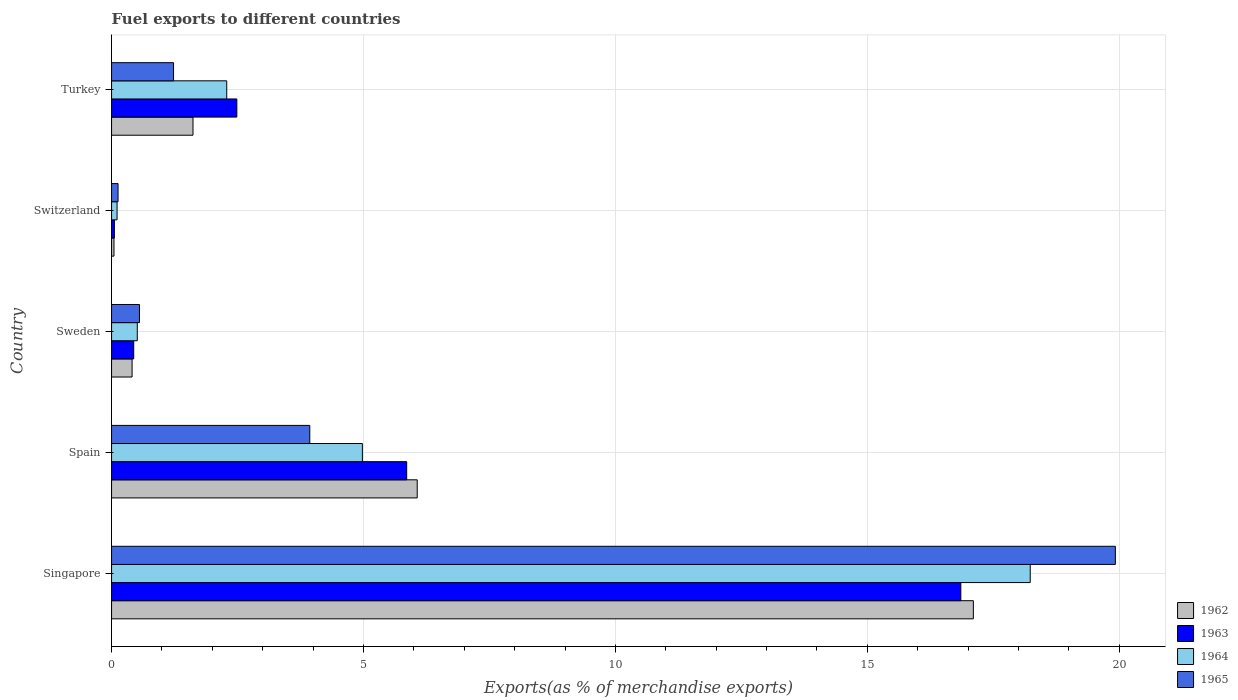How many different coloured bars are there?
Your response must be concise. 4. How many bars are there on the 5th tick from the top?
Provide a succinct answer. 4. How many bars are there on the 2nd tick from the bottom?
Your response must be concise. 4. What is the percentage of exports to different countries in 1962 in Singapore?
Make the answer very short. 17.1. Across all countries, what is the maximum percentage of exports to different countries in 1965?
Your response must be concise. 19.92. Across all countries, what is the minimum percentage of exports to different countries in 1965?
Offer a terse response. 0.13. In which country was the percentage of exports to different countries in 1962 maximum?
Your answer should be compact. Singapore. In which country was the percentage of exports to different countries in 1965 minimum?
Your answer should be compact. Switzerland. What is the total percentage of exports to different countries in 1965 in the graph?
Keep it short and to the point. 25.77. What is the difference between the percentage of exports to different countries in 1965 in Switzerland and that in Turkey?
Offer a terse response. -1.1. What is the difference between the percentage of exports to different countries in 1962 in Switzerland and the percentage of exports to different countries in 1963 in Turkey?
Make the answer very short. -2.44. What is the average percentage of exports to different countries in 1963 per country?
Provide a short and direct response. 5.14. What is the difference between the percentage of exports to different countries in 1964 and percentage of exports to different countries in 1962 in Singapore?
Your answer should be very brief. 1.13. In how many countries, is the percentage of exports to different countries in 1962 greater than 6 %?
Your response must be concise. 2. What is the ratio of the percentage of exports to different countries in 1964 in Spain to that in Switzerland?
Offer a very short reply. 45.62. Is the difference between the percentage of exports to different countries in 1964 in Singapore and Turkey greater than the difference between the percentage of exports to different countries in 1962 in Singapore and Turkey?
Your response must be concise. Yes. What is the difference between the highest and the second highest percentage of exports to different countries in 1964?
Make the answer very short. 13.25. What is the difference between the highest and the lowest percentage of exports to different countries in 1963?
Provide a succinct answer. 16.8. Is the sum of the percentage of exports to different countries in 1965 in Spain and Turkey greater than the maximum percentage of exports to different countries in 1962 across all countries?
Ensure brevity in your answer.  No. Is it the case that in every country, the sum of the percentage of exports to different countries in 1964 and percentage of exports to different countries in 1962 is greater than the sum of percentage of exports to different countries in 1963 and percentage of exports to different countries in 1965?
Ensure brevity in your answer.  No. What does the 2nd bar from the bottom in Spain represents?
Your answer should be very brief. 1963. How many countries are there in the graph?
Give a very brief answer. 5. What is the difference between two consecutive major ticks on the X-axis?
Offer a very short reply. 5. Are the values on the major ticks of X-axis written in scientific E-notation?
Your response must be concise. No. Does the graph contain grids?
Make the answer very short. Yes. How many legend labels are there?
Make the answer very short. 4. How are the legend labels stacked?
Make the answer very short. Vertical. What is the title of the graph?
Offer a very short reply. Fuel exports to different countries. Does "1977" appear as one of the legend labels in the graph?
Your answer should be compact. No. What is the label or title of the X-axis?
Provide a short and direct response. Exports(as % of merchandise exports). What is the Exports(as % of merchandise exports) of 1962 in Singapore?
Give a very brief answer. 17.1. What is the Exports(as % of merchandise exports) in 1963 in Singapore?
Offer a terse response. 16.85. What is the Exports(as % of merchandise exports) in 1964 in Singapore?
Make the answer very short. 18.23. What is the Exports(as % of merchandise exports) in 1965 in Singapore?
Make the answer very short. 19.92. What is the Exports(as % of merchandise exports) of 1962 in Spain?
Ensure brevity in your answer.  6.07. What is the Exports(as % of merchandise exports) of 1963 in Spain?
Your answer should be very brief. 5.86. What is the Exports(as % of merchandise exports) in 1964 in Spain?
Ensure brevity in your answer.  4.98. What is the Exports(as % of merchandise exports) in 1965 in Spain?
Give a very brief answer. 3.93. What is the Exports(as % of merchandise exports) in 1962 in Sweden?
Keep it short and to the point. 0.41. What is the Exports(as % of merchandise exports) of 1963 in Sweden?
Your response must be concise. 0.44. What is the Exports(as % of merchandise exports) of 1964 in Sweden?
Give a very brief answer. 0.51. What is the Exports(as % of merchandise exports) in 1965 in Sweden?
Provide a succinct answer. 0.55. What is the Exports(as % of merchandise exports) of 1962 in Switzerland?
Your answer should be compact. 0.05. What is the Exports(as % of merchandise exports) in 1963 in Switzerland?
Make the answer very short. 0.06. What is the Exports(as % of merchandise exports) in 1964 in Switzerland?
Keep it short and to the point. 0.11. What is the Exports(as % of merchandise exports) of 1965 in Switzerland?
Offer a very short reply. 0.13. What is the Exports(as % of merchandise exports) in 1962 in Turkey?
Ensure brevity in your answer.  1.62. What is the Exports(as % of merchandise exports) of 1963 in Turkey?
Keep it short and to the point. 2.49. What is the Exports(as % of merchandise exports) of 1964 in Turkey?
Your answer should be compact. 2.29. What is the Exports(as % of merchandise exports) in 1965 in Turkey?
Provide a succinct answer. 1.23. Across all countries, what is the maximum Exports(as % of merchandise exports) in 1962?
Give a very brief answer. 17.1. Across all countries, what is the maximum Exports(as % of merchandise exports) in 1963?
Keep it short and to the point. 16.85. Across all countries, what is the maximum Exports(as % of merchandise exports) in 1964?
Offer a very short reply. 18.23. Across all countries, what is the maximum Exports(as % of merchandise exports) of 1965?
Offer a very short reply. 19.92. Across all countries, what is the minimum Exports(as % of merchandise exports) of 1962?
Make the answer very short. 0.05. Across all countries, what is the minimum Exports(as % of merchandise exports) of 1963?
Make the answer very short. 0.06. Across all countries, what is the minimum Exports(as % of merchandise exports) of 1964?
Offer a terse response. 0.11. Across all countries, what is the minimum Exports(as % of merchandise exports) of 1965?
Offer a very short reply. 0.13. What is the total Exports(as % of merchandise exports) of 1962 in the graph?
Keep it short and to the point. 25.24. What is the total Exports(as % of merchandise exports) in 1963 in the graph?
Offer a very short reply. 25.69. What is the total Exports(as % of merchandise exports) of 1964 in the graph?
Make the answer very short. 26.12. What is the total Exports(as % of merchandise exports) of 1965 in the graph?
Offer a terse response. 25.77. What is the difference between the Exports(as % of merchandise exports) of 1962 in Singapore and that in Spain?
Your response must be concise. 11.04. What is the difference between the Exports(as % of merchandise exports) in 1963 in Singapore and that in Spain?
Your answer should be compact. 11. What is the difference between the Exports(as % of merchandise exports) in 1964 in Singapore and that in Spain?
Give a very brief answer. 13.25. What is the difference between the Exports(as % of merchandise exports) of 1965 in Singapore and that in Spain?
Offer a terse response. 15.99. What is the difference between the Exports(as % of merchandise exports) in 1962 in Singapore and that in Sweden?
Offer a terse response. 16.7. What is the difference between the Exports(as % of merchandise exports) in 1963 in Singapore and that in Sweden?
Your answer should be very brief. 16.42. What is the difference between the Exports(as % of merchandise exports) of 1964 in Singapore and that in Sweden?
Keep it short and to the point. 17.72. What is the difference between the Exports(as % of merchandise exports) in 1965 in Singapore and that in Sweden?
Keep it short and to the point. 19.37. What is the difference between the Exports(as % of merchandise exports) in 1962 in Singapore and that in Switzerland?
Your answer should be compact. 17.06. What is the difference between the Exports(as % of merchandise exports) in 1963 in Singapore and that in Switzerland?
Provide a succinct answer. 16.8. What is the difference between the Exports(as % of merchandise exports) of 1964 in Singapore and that in Switzerland?
Offer a very short reply. 18.12. What is the difference between the Exports(as % of merchandise exports) in 1965 in Singapore and that in Switzerland?
Keep it short and to the point. 19.79. What is the difference between the Exports(as % of merchandise exports) of 1962 in Singapore and that in Turkey?
Your response must be concise. 15.49. What is the difference between the Exports(as % of merchandise exports) in 1963 in Singapore and that in Turkey?
Offer a very short reply. 14.37. What is the difference between the Exports(as % of merchandise exports) in 1964 in Singapore and that in Turkey?
Ensure brevity in your answer.  15.95. What is the difference between the Exports(as % of merchandise exports) of 1965 in Singapore and that in Turkey?
Ensure brevity in your answer.  18.69. What is the difference between the Exports(as % of merchandise exports) of 1962 in Spain and that in Sweden?
Give a very brief answer. 5.66. What is the difference between the Exports(as % of merchandise exports) of 1963 in Spain and that in Sweden?
Your answer should be very brief. 5.42. What is the difference between the Exports(as % of merchandise exports) of 1964 in Spain and that in Sweden?
Offer a terse response. 4.47. What is the difference between the Exports(as % of merchandise exports) in 1965 in Spain and that in Sweden?
Make the answer very short. 3.38. What is the difference between the Exports(as % of merchandise exports) in 1962 in Spain and that in Switzerland?
Keep it short and to the point. 6.02. What is the difference between the Exports(as % of merchandise exports) in 1963 in Spain and that in Switzerland?
Give a very brief answer. 5.8. What is the difference between the Exports(as % of merchandise exports) of 1964 in Spain and that in Switzerland?
Your response must be concise. 4.87. What is the difference between the Exports(as % of merchandise exports) of 1965 in Spain and that in Switzerland?
Provide a succinct answer. 3.81. What is the difference between the Exports(as % of merchandise exports) in 1962 in Spain and that in Turkey?
Keep it short and to the point. 4.45. What is the difference between the Exports(as % of merchandise exports) in 1963 in Spain and that in Turkey?
Provide a succinct answer. 3.37. What is the difference between the Exports(as % of merchandise exports) in 1964 in Spain and that in Turkey?
Provide a succinct answer. 2.69. What is the difference between the Exports(as % of merchandise exports) in 1965 in Spain and that in Turkey?
Keep it short and to the point. 2.7. What is the difference between the Exports(as % of merchandise exports) in 1962 in Sweden and that in Switzerland?
Your response must be concise. 0.36. What is the difference between the Exports(as % of merchandise exports) in 1963 in Sweden and that in Switzerland?
Your answer should be compact. 0.38. What is the difference between the Exports(as % of merchandise exports) of 1964 in Sweden and that in Switzerland?
Make the answer very short. 0.4. What is the difference between the Exports(as % of merchandise exports) in 1965 in Sweden and that in Switzerland?
Offer a very short reply. 0.43. What is the difference between the Exports(as % of merchandise exports) in 1962 in Sweden and that in Turkey?
Your answer should be compact. -1.21. What is the difference between the Exports(as % of merchandise exports) of 1963 in Sweden and that in Turkey?
Keep it short and to the point. -2.05. What is the difference between the Exports(as % of merchandise exports) of 1964 in Sweden and that in Turkey?
Ensure brevity in your answer.  -1.78. What is the difference between the Exports(as % of merchandise exports) of 1965 in Sweden and that in Turkey?
Offer a terse response. -0.68. What is the difference between the Exports(as % of merchandise exports) in 1962 in Switzerland and that in Turkey?
Give a very brief answer. -1.57. What is the difference between the Exports(as % of merchandise exports) of 1963 in Switzerland and that in Turkey?
Offer a very short reply. -2.43. What is the difference between the Exports(as % of merchandise exports) in 1964 in Switzerland and that in Turkey?
Offer a very short reply. -2.18. What is the difference between the Exports(as % of merchandise exports) of 1965 in Switzerland and that in Turkey?
Ensure brevity in your answer.  -1.1. What is the difference between the Exports(as % of merchandise exports) of 1962 in Singapore and the Exports(as % of merchandise exports) of 1963 in Spain?
Keep it short and to the point. 11.25. What is the difference between the Exports(as % of merchandise exports) in 1962 in Singapore and the Exports(as % of merchandise exports) in 1964 in Spain?
Ensure brevity in your answer.  12.13. What is the difference between the Exports(as % of merchandise exports) in 1962 in Singapore and the Exports(as % of merchandise exports) in 1965 in Spain?
Offer a very short reply. 13.17. What is the difference between the Exports(as % of merchandise exports) of 1963 in Singapore and the Exports(as % of merchandise exports) of 1964 in Spain?
Give a very brief answer. 11.88. What is the difference between the Exports(as % of merchandise exports) in 1963 in Singapore and the Exports(as % of merchandise exports) in 1965 in Spain?
Your answer should be compact. 12.92. What is the difference between the Exports(as % of merchandise exports) in 1964 in Singapore and the Exports(as % of merchandise exports) in 1965 in Spain?
Your answer should be compact. 14.3. What is the difference between the Exports(as % of merchandise exports) in 1962 in Singapore and the Exports(as % of merchandise exports) in 1963 in Sweden?
Provide a succinct answer. 16.66. What is the difference between the Exports(as % of merchandise exports) in 1962 in Singapore and the Exports(as % of merchandise exports) in 1964 in Sweden?
Your answer should be very brief. 16.59. What is the difference between the Exports(as % of merchandise exports) in 1962 in Singapore and the Exports(as % of merchandise exports) in 1965 in Sweden?
Provide a short and direct response. 16.55. What is the difference between the Exports(as % of merchandise exports) of 1963 in Singapore and the Exports(as % of merchandise exports) of 1964 in Sweden?
Your answer should be very brief. 16.34. What is the difference between the Exports(as % of merchandise exports) of 1963 in Singapore and the Exports(as % of merchandise exports) of 1965 in Sweden?
Give a very brief answer. 16.3. What is the difference between the Exports(as % of merchandise exports) in 1964 in Singapore and the Exports(as % of merchandise exports) in 1965 in Sweden?
Make the answer very short. 17.68. What is the difference between the Exports(as % of merchandise exports) in 1962 in Singapore and the Exports(as % of merchandise exports) in 1963 in Switzerland?
Provide a succinct answer. 17.05. What is the difference between the Exports(as % of merchandise exports) of 1962 in Singapore and the Exports(as % of merchandise exports) of 1964 in Switzerland?
Keep it short and to the point. 16.99. What is the difference between the Exports(as % of merchandise exports) in 1962 in Singapore and the Exports(as % of merchandise exports) in 1965 in Switzerland?
Ensure brevity in your answer.  16.97. What is the difference between the Exports(as % of merchandise exports) of 1963 in Singapore and the Exports(as % of merchandise exports) of 1964 in Switzerland?
Provide a succinct answer. 16.75. What is the difference between the Exports(as % of merchandise exports) in 1963 in Singapore and the Exports(as % of merchandise exports) in 1965 in Switzerland?
Your response must be concise. 16.73. What is the difference between the Exports(as % of merchandise exports) in 1964 in Singapore and the Exports(as % of merchandise exports) in 1965 in Switzerland?
Your answer should be compact. 18.1. What is the difference between the Exports(as % of merchandise exports) in 1962 in Singapore and the Exports(as % of merchandise exports) in 1963 in Turkey?
Your answer should be compact. 14.62. What is the difference between the Exports(as % of merchandise exports) in 1962 in Singapore and the Exports(as % of merchandise exports) in 1964 in Turkey?
Your answer should be compact. 14.82. What is the difference between the Exports(as % of merchandise exports) of 1962 in Singapore and the Exports(as % of merchandise exports) of 1965 in Turkey?
Offer a terse response. 15.87. What is the difference between the Exports(as % of merchandise exports) of 1963 in Singapore and the Exports(as % of merchandise exports) of 1964 in Turkey?
Your answer should be compact. 14.57. What is the difference between the Exports(as % of merchandise exports) in 1963 in Singapore and the Exports(as % of merchandise exports) in 1965 in Turkey?
Give a very brief answer. 15.62. What is the difference between the Exports(as % of merchandise exports) in 1964 in Singapore and the Exports(as % of merchandise exports) in 1965 in Turkey?
Give a very brief answer. 17. What is the difference between the Exports(as % of merchandise exports) in 1962 in Spain and the Exports(as % of merchandise exports) in 1963 in Sweden?
Provide a succinct answer. 5.63. What is the difference between the Exports(as % of merchandise exports) of 1962 in Spain and the Exports(as % of merchandise exports) of 1964 in Sweden?
Your answer should be compact. 5.56. What is the difference between the Exports(as % of merchandise exports) of 1962 in Spain and the Exports(as % of merchandise exports) of 1965 in Sweden?
Your answer should be very brief. 5.51. What is the difference between the Exports(as % of merchandise exports) in 1963 in Spain and the Exports(as % of merchandise exports) in 1964 in Sweden?
Give a very brief answer. 5.35. What is the difference between the Exports(as % of merchandise exports) of 1963 in Spain and the Exports(as % of merchandise exports) of 1965 in Sweden?
Provide a short and direct response. 5.3. What is the difference between the Exports(as % of merchandise exports) in 1964 in Spain and the Exports(as % of merchandise exports) in 1965 in Sweden?
Your response must be concise. 4.42. What is the difference between the Exports(as % of merchandise exports) of 1962 in Spain and the Exports(as % of merchandise exports) of 1963 in Switzerland?
Offer a terse response. 6.01. What is the difference between the Exports(as % of merchandise exports) of 1962 in Spain and the Exports(as % of merchandise exports) of 1964 in Switzerland?
Keep it short and to the point. 5.96. What is the difference between the Exports(as % of merchandise exports) of 1962 in Spain and the Exports(as % of merchandise exports) of 1965 in Switzerland?
Provide a succinct answer. 5.94. What is the difference between the Exports(as % of merchandise exports) in 1963 in Spain and the Exports(as % of merchandise exports) in 1964 in Switzerland?
Keep it short and to the point. 5.75. What is the difference between the Exports(as % of merchandise exports) in 1963 in Spain and the Exports(as % of merchandise exports) in 1965 in Switzerland?
Your answer should be very brief. 5.73. What is the difference between the Exports(as % of merchandise exports) of 1964 in Spain and the Exports(as % of merchandise exports) of 1965 in Switzerland?
Provide a succinct answer. 4.85. What is the difference between the Exports(as % of merchandise exports) in 1962 in Spain and the Exports(as % of merchandise exports) in 1963 in Turkey?
Your answer should be compact. 3.58. What is the difference between the Exports(as % of merchandise exports) of 1962 in Spain and the Exports(as % of merchandise exports) of 1964 in Turkey?
Keep it short and to the point. 3.78. What is the difference between the Exports(as % of merchandise exports) of 1962 in Spain and the Exports(as % of merchandise exports) of 1965 in Turkey?
Your response must be concise. 4.84. What is the difference between the Exports(as % of merchandise exports) in 1963 in Spain and the Exports(as % of merchandise exports) in 1964 in Turkey?
Ensure brevity in your answer.  3.57. What is the difference between the Exports(as % of merchandise exports) of 1963 in Spain and the Exports(as % of merchandise exports) of 1965 in Turkey?
Ensure brevity in your answer.  4.63. What is the difference between the Exports(as % of merchandise exports) of 1964 in Spain and the Exports(as % of merchandise exports) of 1965 in Turkey?
Make the answer very short. 3.75. What is the difference between the Exports(as % of merchandise exports) of 1962 in Sweden and the Exports(as % of merchandise exports) of 1963 in Switzerland?
Make the answer very short. 0.35. What is the difference between the Exports(as % of merchandise exports) in 1962 in Sweden and the Exports(as % of merchandise exports) in 1964 in Switzerland?
Your answer should be compact. 0.3. What is the difference between the Exports(as % of merchandise exports) in 1962 in Sweden and the Exports(as % of merchandise exports) in 1965 in Switzerland?
Your answer should be very brief. 0.28. What is the difference between the Exports(as % of merchandise exports) of 1963 in Sweden and the Exports(as % of merchandise exports) of 1964 in Switzerland?
Ensure brevity in your answer.  0.33. What is the difference between the Exports(as % of merchandise exports) in 1963 in Sweden and the Exports(as % of merchandise exports) in 1965 in Switzerland?
Your answer should be compact. 0.31. What is the difference between the Exports(as % of merchandise exports) in 1964 in Sweden and the Exports(as % of merchandise exports) in 1965 in Switzerland?
Your response must be concise. 0.38. What is the difference between the Exports(as % of merchandise exports) in 1962 in Sweden and the Exports(as % of merchandise exports) in 1963 in Turkey?
Make the answer very short. -2.08. What is the difference between the Exports(as % of merchandise exports) in 1962 in Sweden and the Exports(as % of merchandise exports) in 1964 in Turkey?
Offer a terse response. -1.88. What is the difference between the Exports(as % of merchandise exports) of 1962 in Sweden and the Exports(as % of merchandise exports) of 1965 in Turkey?
Your answer should be compact. -0.82. What is the difference between the Exports(as % of merchandise exports) in 1963 in Sweden and the Exports(as % of merchandise exports) in 1964 in Turkey?
Provide a succinct answer. -1.85. What is the difference between the Exports(as % of merchandise exports) in 1963 in Sweden and the Exports(as % of merchandise exports) in 1965 in Turkey?
Give a very brief answer. -0.79. What is the difference between the Exports(as % of merchandise exports) in 1964 in Sweden and the Exports(as % of merchandise exports) in 1965 in Turkey?
Provide a short and direct response. -0.72. What is the difference between the Exports(as % of merchandise exports) in 1962 in Switzerland and the Exports(as % of merchandise exports) in 1963 in Turkey?
Provide a succinct answer. -2.44. What is the difference between the Exports(as % of merchandise exports) in 1962 in Switzerland and the Exports(as % of merchandise exports) in 1964 in Turkey?
Offer a terse response. -2.24. What is the difference between the Exports(as % of merchandise exports) of 1962 in Switzerland and the Exports(as % of merchandise exports) of 1965 in Turkey?
Keep it short and to the point. -1.18. What is the difference between the Exports(as % of merchandise exports) in 1963 in Switzerland and the Exports(as % of merchandise exports) in 1964 in Turkey?
Your answer should be very brief. -2.23. What is the difference between the Exports(as % of merchandise exports) of 1963 in Switzerland and the Exports(as % of merchandise exports) of 1965 in Turkey?
Your answer should be compact. -1.17. What is the difference between the Exports(as % of merchandise exports) of 1964 in Switzerland and the Exports(as % of merchandise exports) of 1965 in Turkey?
Offer a very short reply. -1.12. What is the average Exports(as % of merchandise exports) in 1962 per country?
Make the answer very short. 5.05. What is the average Exports(as % of merchandise exports) of 1963 per country?
Provide a short and direct response. 5.14. What is the average Exports(as % of merchandise exports) in 1964 per country?
Ensure brevity in your answer.  5.22. What is the average Exports(as % of merchandise exports) in 1965 per country?
Your response must be concise. 5.15. What is the difference between the Exports(as % of merchandise exports) in 1962 and Exports(as % of merchandise exports) in 1963 in Singapore?
Offer a very short reply. 0.25. What is the difference between the Exports(as % of merchandise exports) of 1962 and Exports(as % of merchandise exports) of 1964 in Singapore?
Provide a succinct answer. -1.13. What is the difference between the Exports(as % of merchandise exports) in 1962 and Exports(as % of merchandise exports) in 1965 in Singapore?
Your answer should be very brief. -2.82. What is the difference between the Exports(as % of merchandise exports) of 1963 and Exports(as % of merchandise exports) of 1964 in Singapore?
Keep it short and to the point. -1.38. What is the difference between the Exports(as % of merchandise exports) in 1963 and Exports(as % of merchandise exports) in 1965 in Singapore?
Your answer should be compact. -3.07. What is the difference between the Exports(as % of merchandise exports) in 1964 and Exports(as % of merchandise exports) in 1965 in Singapore?
Offer a very short reply. -1.69. What is the difference between the Exports(as % of merchandise exports) of 1962 and Exports(as % of merchandise exports) of 1963 in Spain?
Offer a very short reply. 0.21. What is the difference between the Exports(as % of merchandise exports) in 1962 and Exports(as % of merchandise exports) in 1964 in Spain?
Offer a very short reply. 1.09. What is the difference between the Exports(as % of merchandise exports) in 1962 and Exports(as % of merchandise exports) in 1965 in Spain?
Give a very brief answer. 2.13. What is the difference between the Exports(as % of merchandise exports) of 1963 and Exports(as % of merchandise exports) of 1964 in Spain?
Your answer should be compact. 0.88. What is the difference between the Exports(as % of merchandise exports) of 1963 and Exports(as % of merchandise exports) of 1965 in Spain?
Your response must be concise. 1.92. What is the difference between the Exports(as % of merchandise exports) of 1964 and Exports(as % of merchandise exports) of 1965 in Spain?
Keep it short and to the point. 1.04. What is the difference between the Exports(as % of merchandise exports) of 1962 and Exports(as % of merchandise exports) of 1963 in Sweden?
Make the answer very short. -0.03. What is the difference between the Exports(as % of merchandise exports) in 1962 and Exports(as % of merchandise exports) in 1964 in Sweden?
Provide a short and direct response. -0.1. What is the difference between the Exports(as % of merchandise exports) of 1962 and Exports(as % of merchandise exports) of 1965 in Sweden?
Offer a very short reply. -0.15. What is the difference between the Exports(as % of merchandise exports) of 1963 and Exports(as % of merchandise exports) of 1964 in Sweden?
Your answer should be compact. -0.07. What is the difference between the Exports(as % of merchandise exports) of 1963 and Exports(as % of merchandise exports) of 1965 in Sweden?
Make the answer very short. -0.12. What is the difference between the Exports(as % of merchandise exports) in 1964 and Exports(as % of merchandise exports) in 1965 in Sweden?
Offer a very short reply. -0.04. What is the difference between the Exports(as % of merchandise exports) in 1962 and Exports(as % of merchandise exports) in 1963 in Switzerland?
Offer a terse response. -0.01. What is the difference between the Exports(as % of merchandise exports) in 1962 and Exports(as % of merchandise exports) in 1964 in Switzerland?
Keep it short and to the point. -0.06. What is the difference between the Exports(as % of merchandise exports) in 1962 and Exports(as % of merchandise exports) in 1965 in Switzerland?
Provide a succinct answer. -0.08. What is the difference between the Exports(as % of merchandise exports) in 1963 and Exports(as % of merchandise exports) in 1964 in Switzerland?
Give a very brief answer. -0.05. What is the difference between the Exports(as % of merchandise exports) of 1963 and Exports(as % of merchandise exports) of 1965 in Switzerland?
Offer a very short reply. -0.07. What is the difference between the Exports(as % of merchandise exports) in 1964 and Exports(as % of merchandise exports) in 1965 in Switzerland?
Provide a succinct answer. -0.02. What is the difference between the Exports(as % of merchandise exports) of 1962 and Exports(as % of merchandise exports) of 1963 in Turkey?
Provide a short and direct response. -0.87. What is the difference between the Exports(as % of merchandise exports) in 1962 and Exports(as % of merchandise exports) in 1964 in Turkey?
Provide a short and direct response. -0.67. What is the difference between the Exports(as % of merchandise exports) in 1962 and Exports(as % of merchandise exports) in 1965 in Turkey?
Keep it short and to the point. 0.39. What is the difference between the Exports(as % of merchandise exports) of 1963 and Exports(as % of merchandise exports) of 1964 in Turkey?
Provide a succinct answer. 0.2. What is the difference between the Exports(as % of merchandise exports) in 1963 and Exports(as % of merchandise exports) in 1965 in Turkey?
Provide a succinct answer. 1.26. What is the difference between the Exports(as % of merchandise exports) in 1964 and Exports(as % of merchandise exports) in 1965 in Turkey?
Give a very brief answer. 1.06. What is the ratio of the Exports(as % of merchandise exports) in 1962 in Singapore to that in Spain?
Provide a succinct answer. 2.82. What is the ratio of the Exports(as % of merchandise exports) in 1963 in Singapore to that in Spain?
Your answer should be compact. 2.88. What is the ratio of the Exports(as % of merchandise exports) of 1964 in Singapore to that in Spain?
Offer a terse response. 3.66. What is the ratio of the Exports(as % of merchandise exports) of 1965 in Singapore to that in Spain?
Your response must be concise. 5.06. What is the ratio of the Exports(as % of merchandise exports) of 1962 in Singapore to that in Sweden?
Keep it short and to the point. 41.99. What is the ratio of the Exports(as % of merchandise exports) of 1963 in Singapore to that in Sweden?
Offer a very short reply. 38.35. What is the ratio of the Exports(as % of merchandise exports) of 1964 in Singapore to that in Sweden?
Keep it short and to the point. 35.72. What is the ratio of the Exports(as % of merchandise exports) of 1965 in Singapore to that in Sweden?
Your answer should be compact. 35.92. What is the ratio of the Exports(as % of merchandise exports) of 1962 in Singapore to that in Switzerland?
Give a very brief answer. 354.54. What is the ratio of the Exports(as % of merchandise exports) in 1963 in Singapore to that in Switzerland?
Provide a succinct answer. 299.62. What is the ratio of the Exports(as % of merchandise exports) of 1964 in Singapore to that in Switzerland?
Ensure brevity in your answer.  167.06. What is the ratio of the Exports(as % of merchandise exports) of 1965 in Singapore to that in Switzerland?
Offer a very short reply. 154.67. What is the ratio of the Exports(as % of merchandise exports) in 1962 in Singapore to that in Turkey?
Your response must be concise. 10.58. What is the ratio of the Exports(as % of merchandise exports) of 1963 in Singapore to that in Turkey?
Give a very brief answer. 6.78. What is the ratio of the Exports(as % of merchandise exports) of 1964 in Singapore to that in Turkey?
Keep it short and to the point. 7.98. What is the ratio of the Exports(as % of merchandise exports) in 1965 in Singapore to that in Turkey?
Your response must be concise. 16.19. What is the ratio of the Exports(as % of merchandise exports) of 1962 in Spain to that in Sweden?
Keep it short and to the point. 14.89. What is the ratio of the Exports(as % of merchandise exports) in 1963 in Spain to that in Sweden?
Offer a very short reply. 13.33. What is the ratio of the Exports(as % of merchandise exports) in 1964 in Spain to that in Sweden?
Offer a very short reply. 9.75. What is the ratio of the Exports(as % of merchandise exports) of 1965 in Spain to that in Sweden?
Offer a terse response. 7.09. What is the ratio of the Exports(as % of merchandise exports) of 1962 in Spain to that in Switzerland?
Give a very brief answer. 125.74. What is the ratio of the Exports(as % of merchandise exports) of 1963 in Spain to that in Switzerland?
Offer a terse response. 104.12. What is the ratio of the Exports(as % of merchandise exports) in 1964 in Spain to that in Switzerland?
Make the answer very short. 45.62. What is the ratio of the Exports(as % of merchandise exports) of 1965 in Spain to that in Switzerland?
Offer a terse response. 30.54. What is the ratio of the Exports(as % of merchandise exports) of 1962 in Spain to that in Turkey?
Your answer should be compact. 3.75. What is the ratio of the Exports(as % of merchandise exports) of 1963 in Spain to that in Turkey?
Keep it short and to the point. 2.36. What is the ratio of the Exports(as % of merchandise exports) of 1964 in Spain to that in Turkey?
Your response must be concise. 2.18. What is the ratio of the Exports(as % of merchandise exports) in 1965 in Spain to that in Turkey?
Give a very brief answer. 3.2. What is the ratio of the Exports(as % of merchandise exports) in 1962 in Sweden to that in Switzerland?
Provide a succinct answer. 8.44. What is the ratio of the Exports(as % of merchandise exports) of 1963 in Sweden to that in Switzerland?
Your answer should be compact. 7.81. What is the ratio of the Exports(as % of merchandise exports) of 1964 in Sweden to that in Switzerland?
Your answer should be compact. 4.68. What is the ratio of the Exports(as % of merchandise exports) in 1965 in Sweden to that in Switzerland?
Give a very brief answer. 4.31. What is the ratio of the Exports(as % of merchandise exports) in 1962 in Sweden to that in Turkey?
Offer a terse response. 0.25. What is the ratio of the Exports(as % of merchandise exports) in 1963 in Sweden to that in Turkey?
Your response must be concise. 0.18. What is the ratio of the Exports(as % of merchandise exports) of 1964 in Sweden to that in Turkey?
Keep it short and to the point. 0.22. What is the ratio of the Exports(as % of merchandise exports) of 1965 in Sweden to that in Turkey?
Provide a short and direct response. 0.45. What is the ratio of the Exports(as % of merchandise exports) of 1962 in Switzerland to that in Turkey?
Provide a succinct answer. 0.03. What is the ratio of the Exports(as % of merchandise exports) of 1963 in Switzerland to that in Turkey?
Your answer should be compact. 0.02. What is the ratio of the Exports(as % of merchandise exports) in 1964 in Switzerland to that in Turkey?
Provide a succinct answer. 0.05. What is the ratio of the Exports(as % of merchandise exports) of 1965 in Switzerland to that in Turkey?
Offer a very short reply. 0.1. What is the difference between the highest and the second highest Exports(as % of merchandise exports) in 1962?
Offer a terse response. 11.04. What is the difference between the highest and the second highest Exports(as % of merchandise exports) in 1963?
Your answer should be compact. 11. What is the difference between the highest and the second highest Exports(as % of merchandise exports) of 1964?
Your response must be concise. 13.25. What is the difference between the highest and the second highest Exports(as % of merchandise exports) of 1965?
Provide a succinct answer. 15.99. What is the difference between the highest and the lowest Exports(as % of merchandise exports) in 1962?
Offer a terse response. 17.06. What is the difference between the highest and the lowest Exports(as % of merchandise exports) of 1963?
Your response must be concise. 16.8. What is the difference between the highest and the lowest Exports(as % of merchandise exports) in 1964?
Offer a very short reply. 18.12. What is the difference between the highest and the lowest Exports(as % of merchandise exports) in 1965?
Your answer should be very brief. 19.79. 